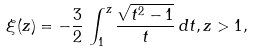Convert formula to latex. <formula><loc_0><loc_0><loc_500><loc_500>\xi ( z ) = - \frac { 3 } { 2 } \, \int _ { 1 } ^ { z } \frac { \sqrt { t ^ { 2 } - 1 } } { t } \, d t , z > 1 ,</formula> 